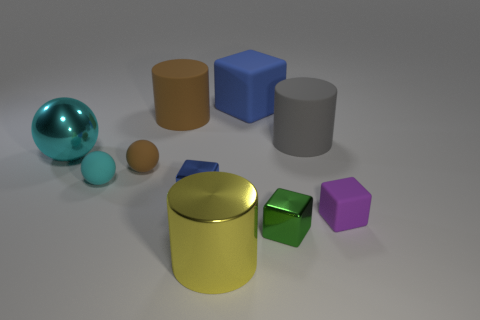How big is the brown cylinder?
Keep it short and to the point. Large. How many other objects are the same material as the small brown sphere?
Provide a succinct answer. 5. Is the cylinder that is to the right of the green cube made of the same material as the tiny cube that is left of the large blue block?
Provide a short and direct response. No. How many shiny things are both behind the yellow metallic object and in front of the purple block?
Make the answer very short. 1. Are there any other cyan rubber things of the same shape as the large cyan thing?
Keep it short and to the point. Yes. The blue object that is the same size as the yellow metal cylinder is what shape?
Give a very brief answer. Cube. Is the number of small brown rubber objects to the left of the small cyan object the same as the number of cubes that are in front of the tiny green shiny thing?
Give a very brief answer. Yes. There is a metallic cube behind the small metallic block in front of the small purple rubber block; how big is it?
Ensure brevity in your answer.  Small. Are there any brown matte objects of the same size as the cyan shiny object?
Your answer should be very brief. Yes. The small block that is the same material as the big cube is what color?
Keep it short and to the point. Purple. 